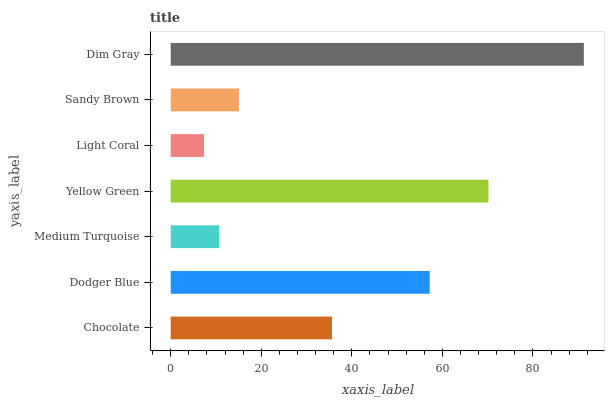Is Light Coral the minimum?
Answer yes or no. Yes. Is Dim Gray the maximum?
Answer yes or no. Yes. Is Dodger Blue the minimum?
Answer yes or no. No. Is Dodger Blue the maximum?
Answer yes or no. No. Is Dodger Blue greater than Chocolate?
Answer yes or no. Yes. Is Chocolate less than Dodger Blue?
Answer yes or no. Yes. Is Chocolate greater than Dodger Blue?
Answer yes or no. No. Is Dodger Blue less than Chocolate?
Answer yes or no. No. Is Chocolate the high median?
Answer yes or no. Yes. Is Chocolate the low median?
Answer yes or no. Yes. Is Sandy Brown the high median?
Answer yes or no. No. Is Medium Turquoise the low median?
Answer yes or no. No. 